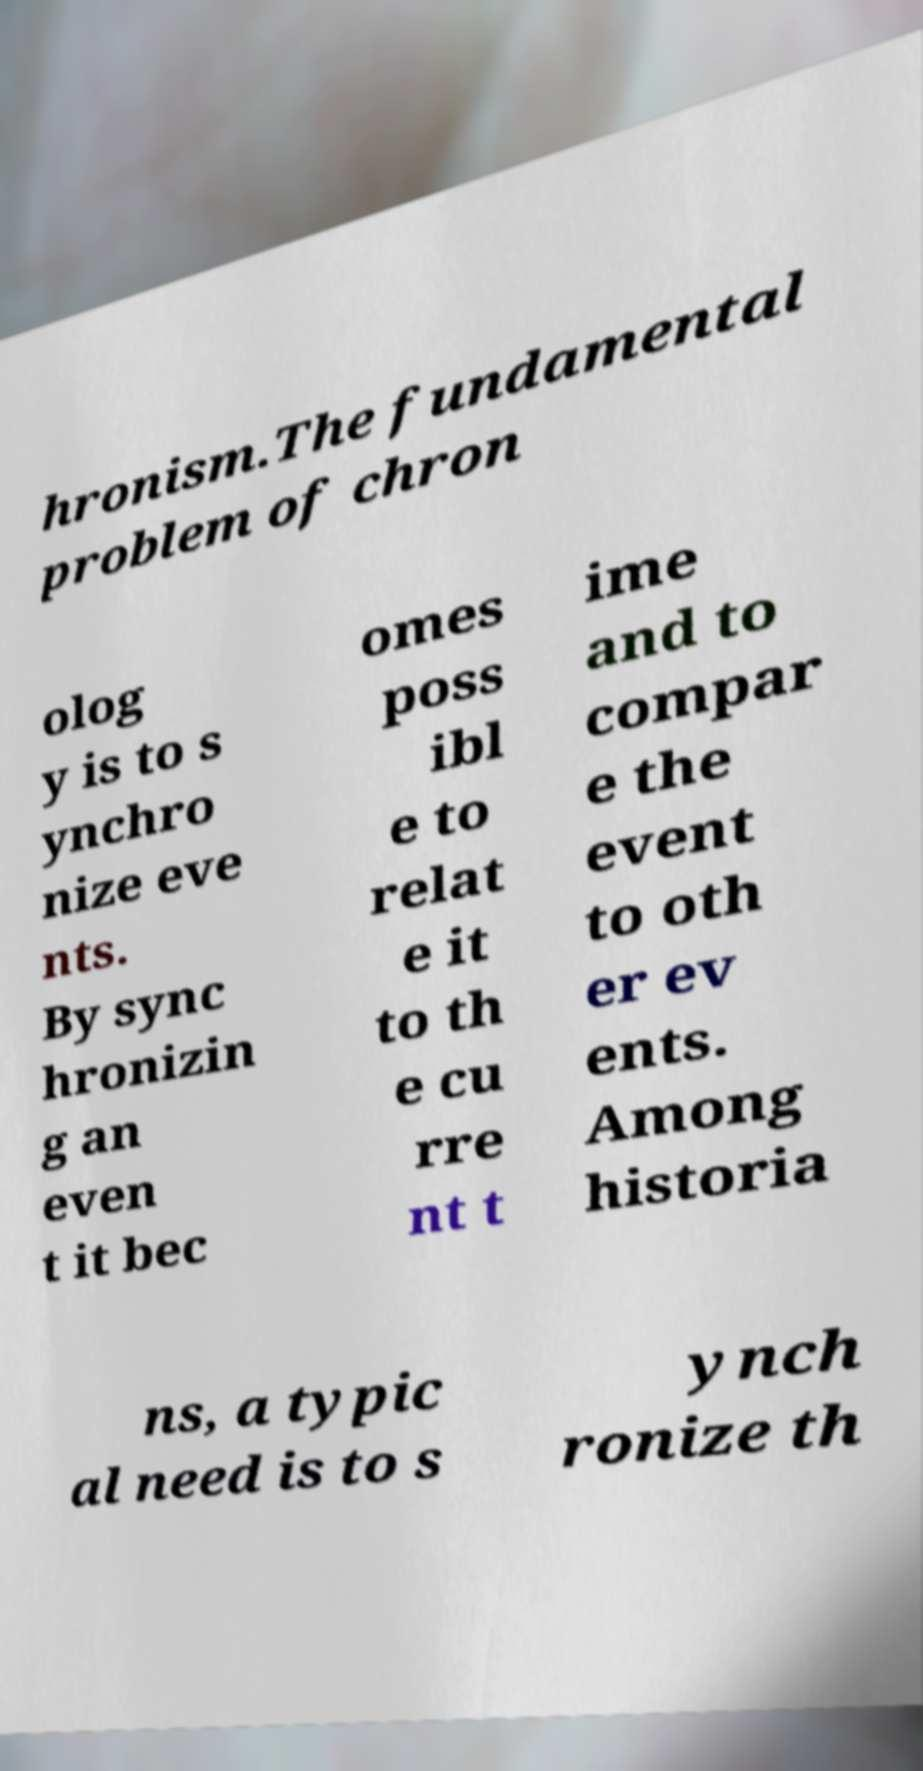Could you assist in decoding the text presented in this image and type it out clearly? hronism.The fundamental problem of chron olog y is to s ynchro nize eve nts. By sync hronizin g an even t it bec omes poss ibl e to relat e it to th e cu rre nt t ime and to compar e the event to oth er ev ents. Among historia ns, a typic al need is to s ynch ronize th 